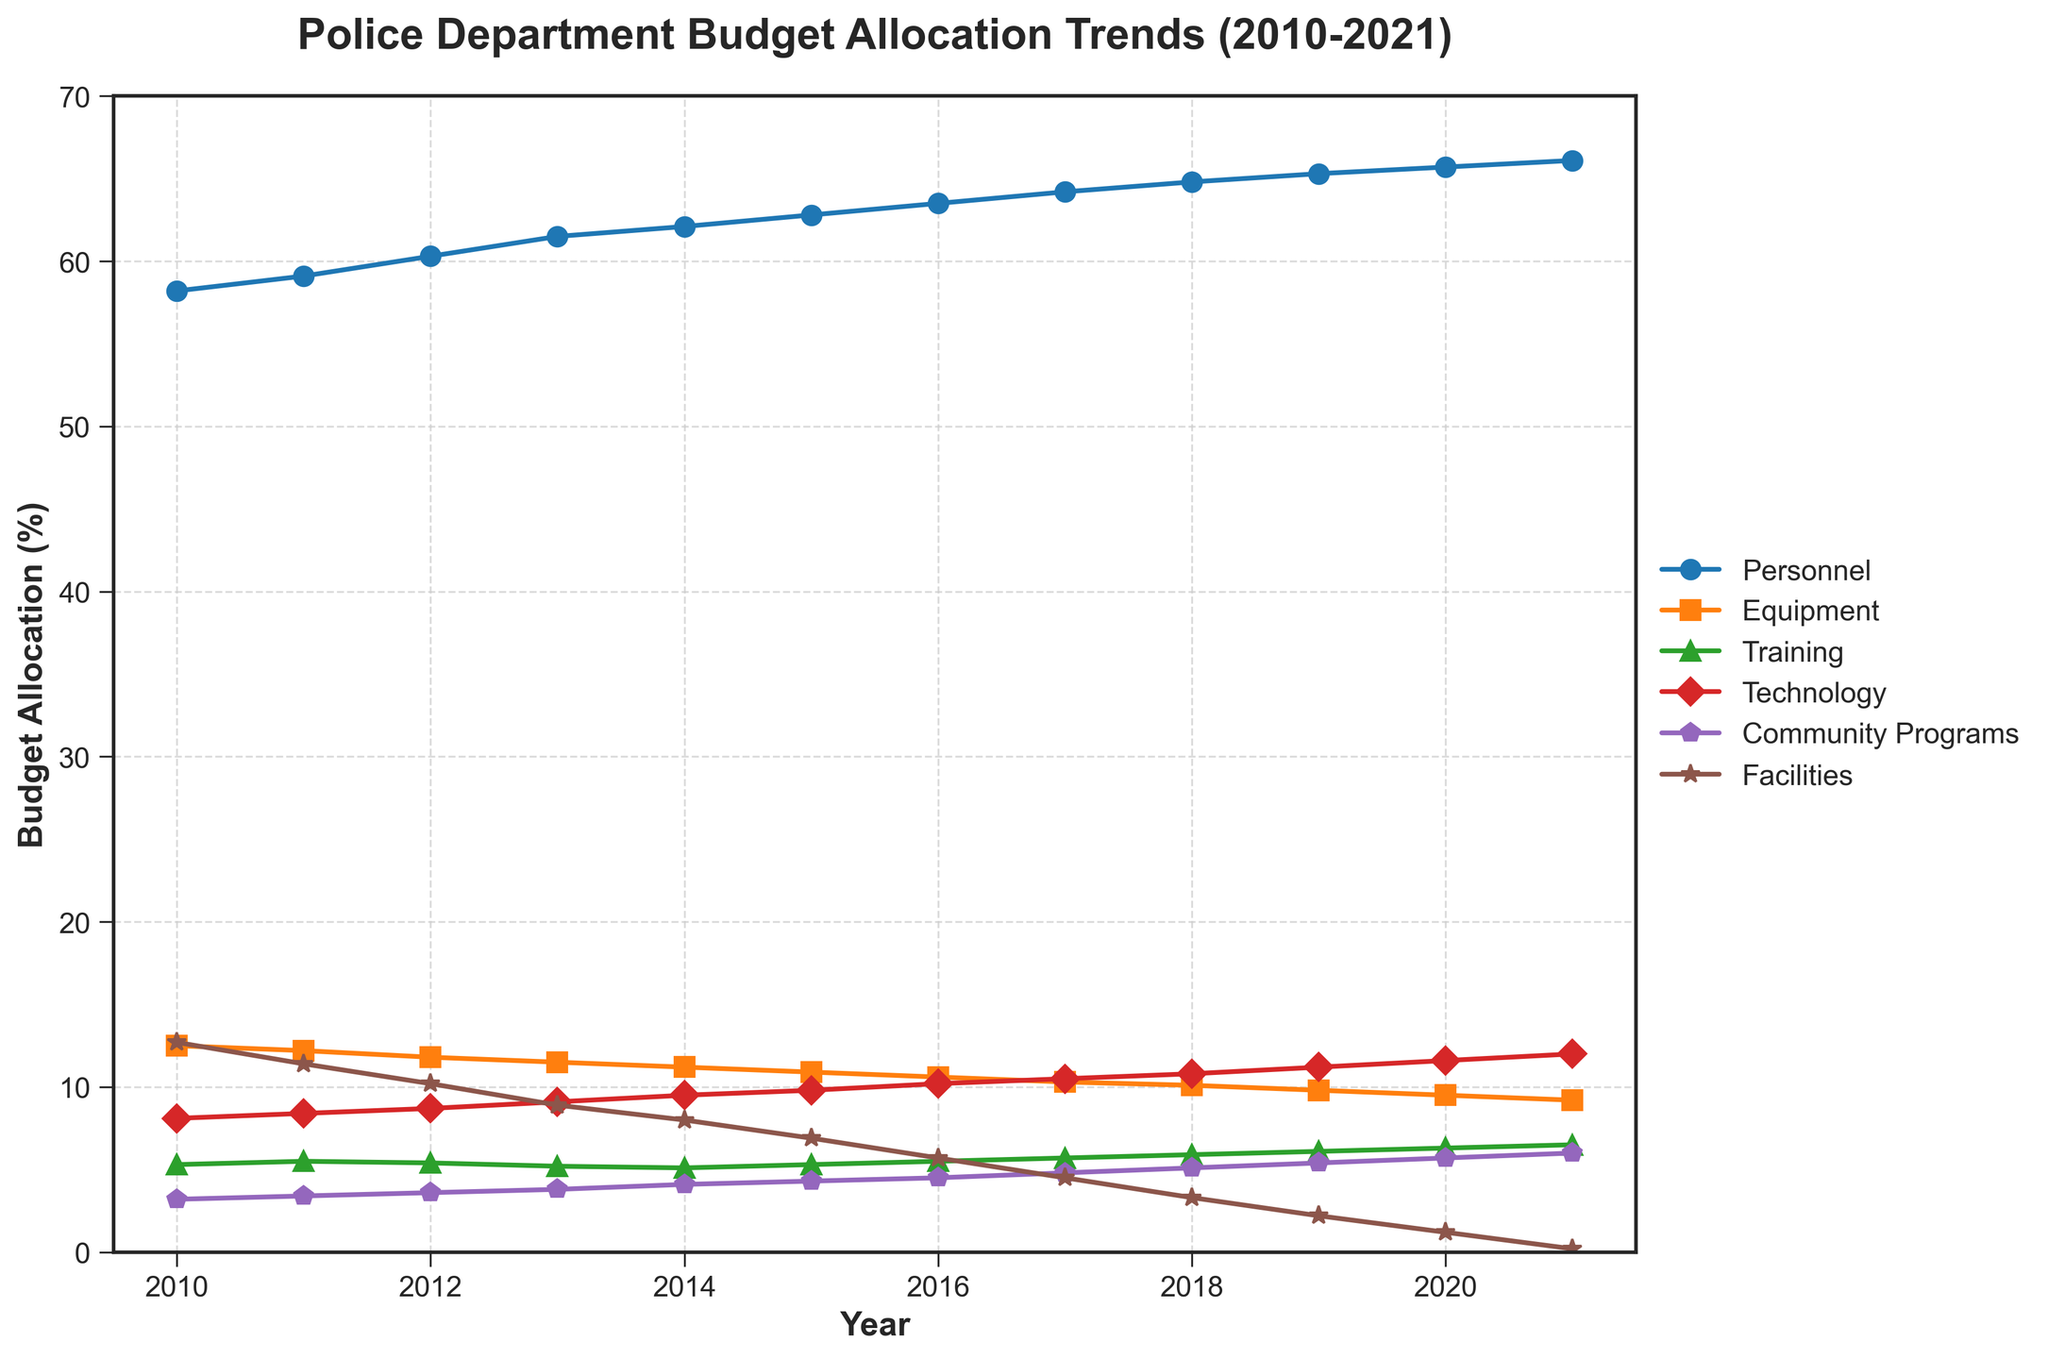Which category had the highest budget allocation in 2021? To determine the highest budget allocation for 2021, look at the endpoints of the lines corresponding to the year 2021 and compare their values. The 'Personnel' category line is noticeably higher than others.
Answer: Personnel How did the budget for Community Programs change from 2010 to 2021? Locate the 'Community Programs' line and compare its value at 2010 and 2021. In 2010, it was at 3.2%, and in 2021, it's at 6.0%. The difference is 6.0 - 3.2 = 2.8%.
Answer: Increased by 2.8% What is the trend in Facility budget allocation over the years? Follow the line for 'Facilities' from 2010 to 2021. Observe that it decreases steadily from around 12.7% to 0.2%.
Answer: Steadily decreasing Which two categories show a consistent increase in budget allocation from 2010 to 2021? Trace the lines for all categories and identify those that show an upward trend from 2010 to 2021. 'Personnel' and 'Community Programs' show consistent increases.
Answer: Personnel and Community Programs In which year did the Equipment budget allocation see the most significant drop? By following the 'Equipment' line, you notice the most significant drop occurred between 2015 (10.9%) and 2016 (10.6%).
Answer: 2015 to 2016 What was the approximate average budget allocation for Training between 2010 and 2021? Sum up the budget allocations for 'Training' over the years and divide by the number of years. (5.3 + 5.5 + 5.4 + 5.2 + 5.1 + 5.3 + 5.5 + 5.7 + 5.9 + 6.1 + 6.3 + 6.5)/12 ≈ 5.6
Answer: 5.6% Identify the year with the highest budget allocation for Technology and state the value. Follow the 'Technology' line and find the peak value, which occurs in 2021 with a value of 12.0%.
Answer: 2021, 12.0% Compare the budget allocations of Facilities and Equipment in 2013. Which category received more funding? Check the values for 'Facilities' and 'Equipment' in 2013. Facilities had 8.9%, and Equipment had 11.5%. Equipment had a higher allocation.
Answer: Equipment How much did the Personnel budget allocation increase from 2010 to 2021? Find the difference between the 2010 and 2021 values. 66.1% (2021) - 58.2% (2010) = 7.9%.
Answer: 7.9% Is there a notable pattern in the changes of the budget allocation for Equipment? Observe the 'Equipment' line over the years; it shows a steady decline with occasional slight increases but a general downward trend.
Answer: General downward trend 